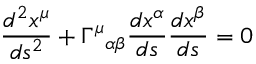Convert formula to latex. <formula><loc_0><loc_0><loc_500><loc_500>{ \frac { d ^ { 2 } x ^ { \mu } } { d s ^ { 2 } } } + \Gamma ^ { \mu _ { \alpha \beta } { \frac { d x ^ { \alpha } } { d s } } { \frac { d x ^ { \beta } } { d s } } = 0</formula> 